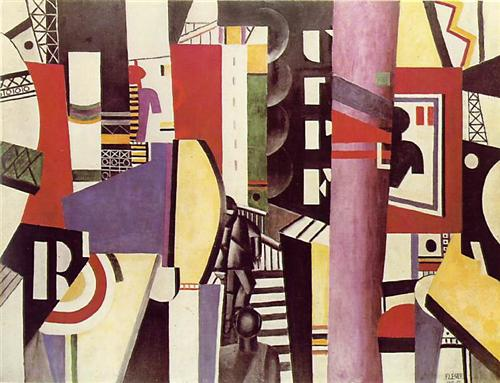Envision this image as part of a dream sequence. What story would the dream depict? In a dream sequence, this image could depict a journey through a surreal and labyrinthine city. The dreamer might find themselves wandering through endless corridors and streets, each turn revealing more abstract intersections and unexpected pathways. The vibrant colors and shifting shapes could represent the fluid and ephemeral nature of dreams, where nothing is quite as it seems and reality is constantly bending. As they navigate this ever-changing landscape, the dreamer might encounter various symbolic figures or objects, each carrying hidden meanings and messages to be deciphered upon waking. This dream could symbolize an introspective quest, filled with wonder, mystery, and self-discovery. 